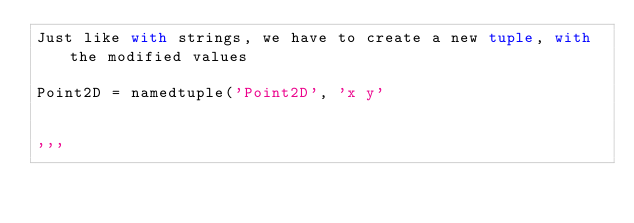<code> <loc_0><loc_0><loc_500><loc_500><_Python_>Just like with strings, we have to create a new tuple, with the modified values

Point2D = namedtuple('Point2D', 'x y'


'''</code> 